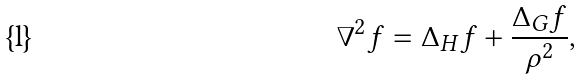<formula> <loc_0><loc_0><loc_500><loc_500>\nabla ^ { 2 } f = \Delta _ { H } f + \frac { \Delta _ { G } f } { \rho ^ { 2 } } ,</formula> 